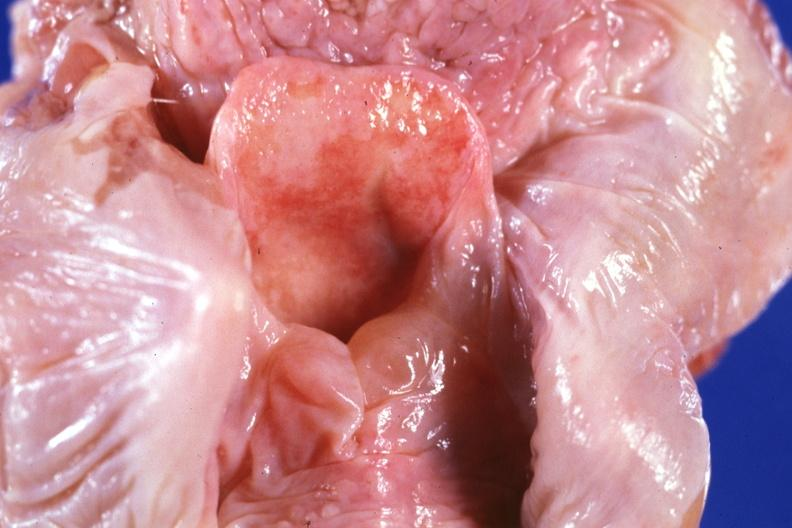s unopened larynx seen from above edema in hypopharynx?
Answer the question using a single word or phrase. Yes 